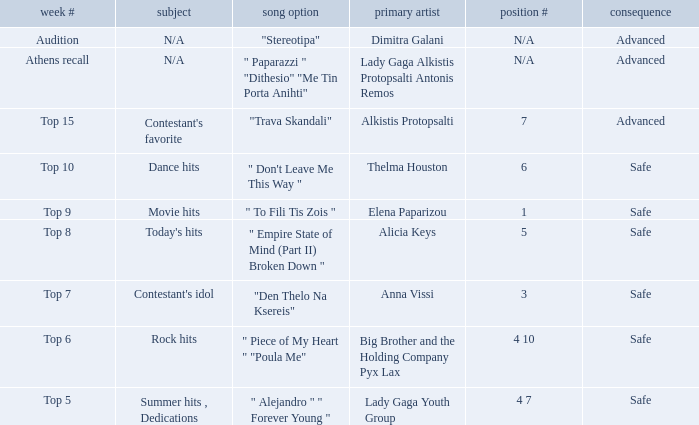Which artists hold sequence number 6? Thelma Houston. 